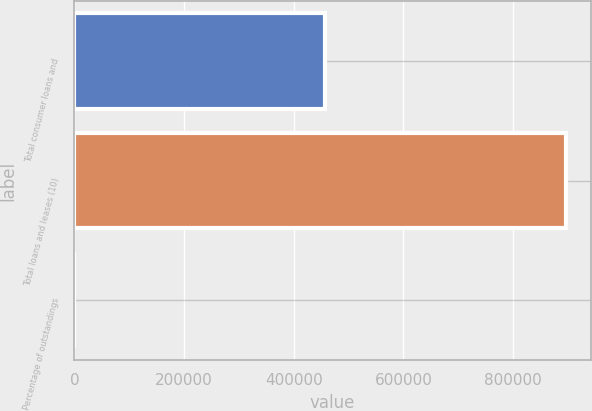Convert chart to OTSL. <chart><loc_0><loc_0><loc_500><loc_500><bar_chart><fcel>Total consumer loans and<fcel>Total loans and leases (10)<fcel>Percentage of outstandings<nl><fcel>456169<fcel>896983<fcel>100<nl></chart> 